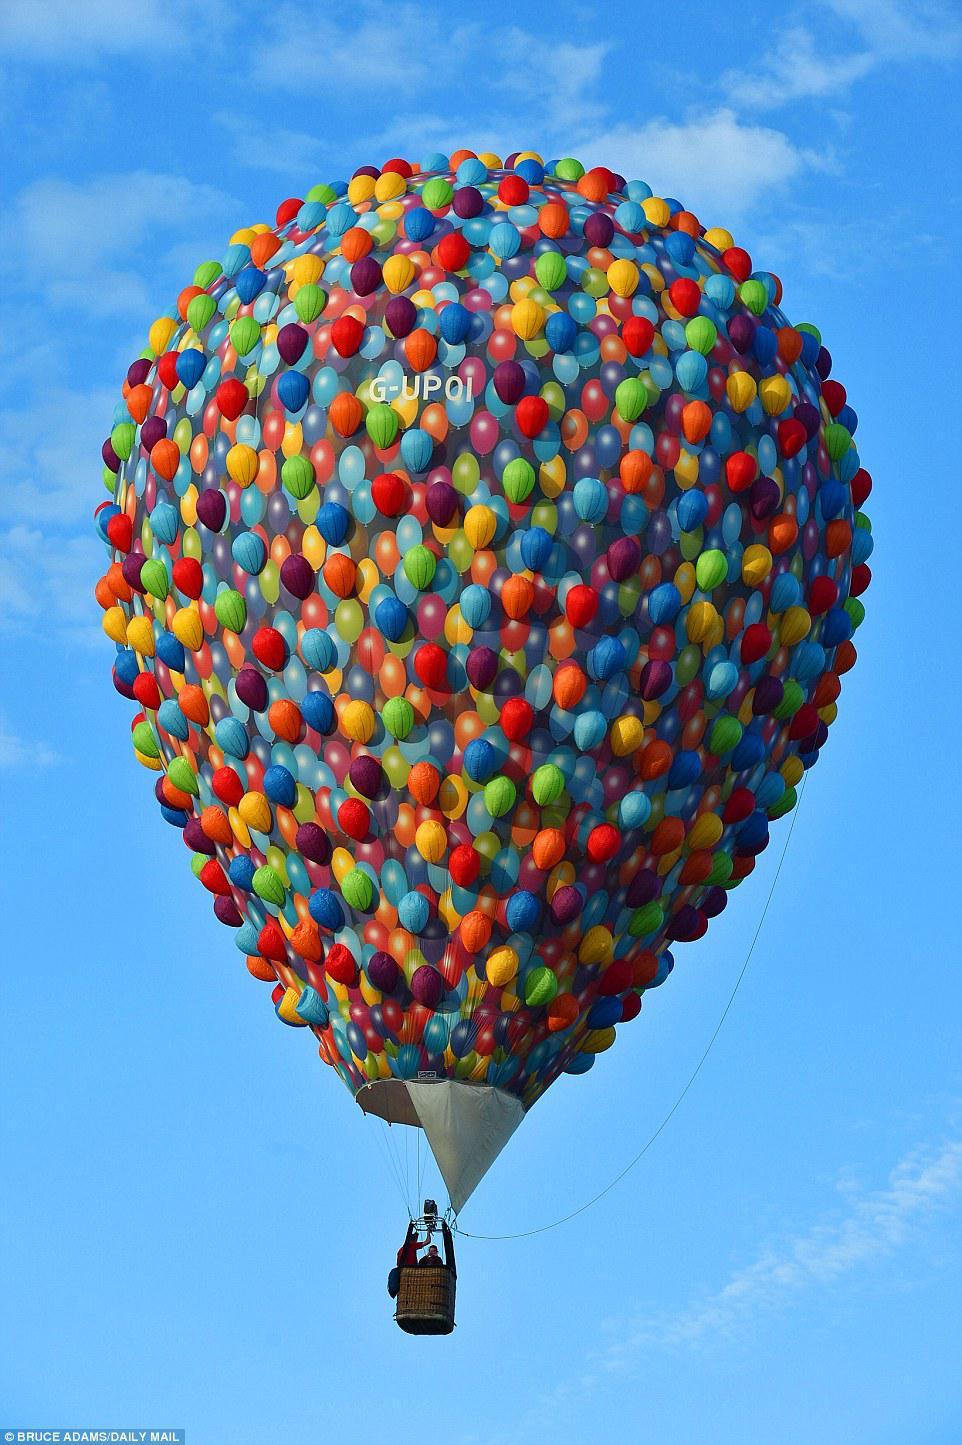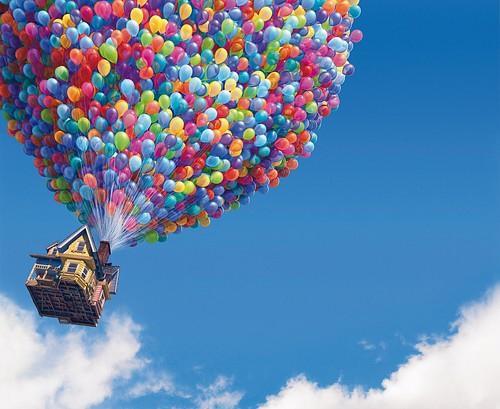The first image is the image on the left, the second image is the image on the right. Considering the images on both sides, is "Only one image shows a hot air balloon made of many balloons." valid? Answer yes or no. No. The first image is the image on the left, the second image is the image on the right. Given the left and right images, does the statement "One hot air balloon appears to be made of many small balloons and its basket is a little house." hold true? Answer yes or no. Yes. 